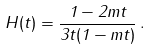<formula> <loc_0><loc_0><loc_500><loc_500>H ( t ) = \frac { 1 - 2 m t } { 3 t ( 1 - m t ) } \, .</formula> 